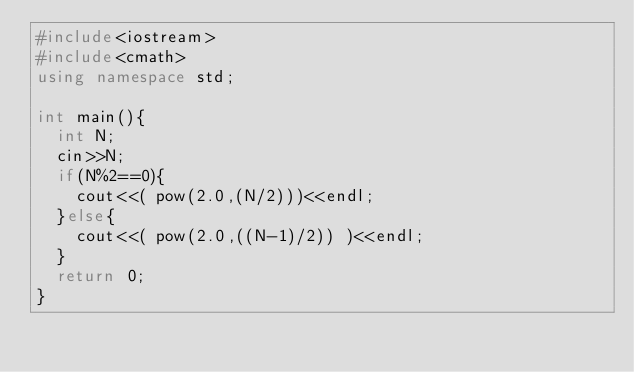Convert code to text. <code><loc_0><loc_0><loc_500><loc_500><_C++_>#include<iostream>
#include<cmath>
using namespace std;

int main(){
	int N;
	cin>>N;
	if(N%2==0){
		cout<<( pow(2.0,(N/2)))<<endl;
	}else{
		cout<<( pow(2.0,((N-1)/2)) )<<endl;
	}
	return 0;
}</code> 